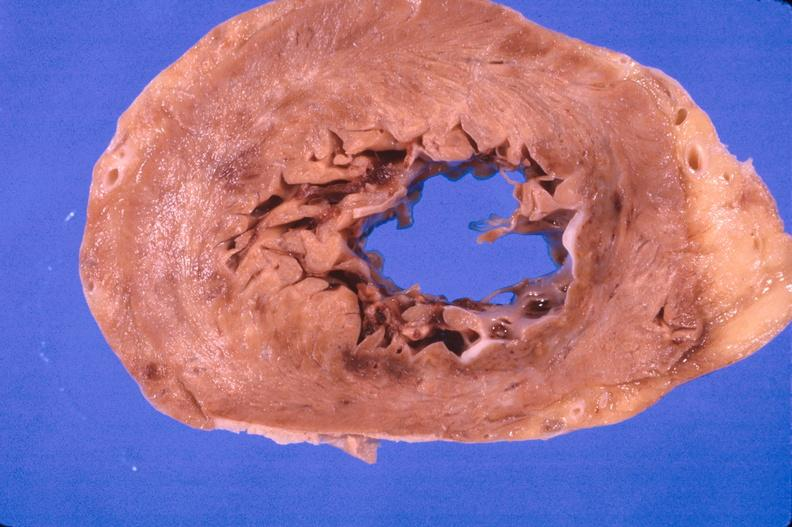where is this?
Answer the question using a single word or phrase. Heart 